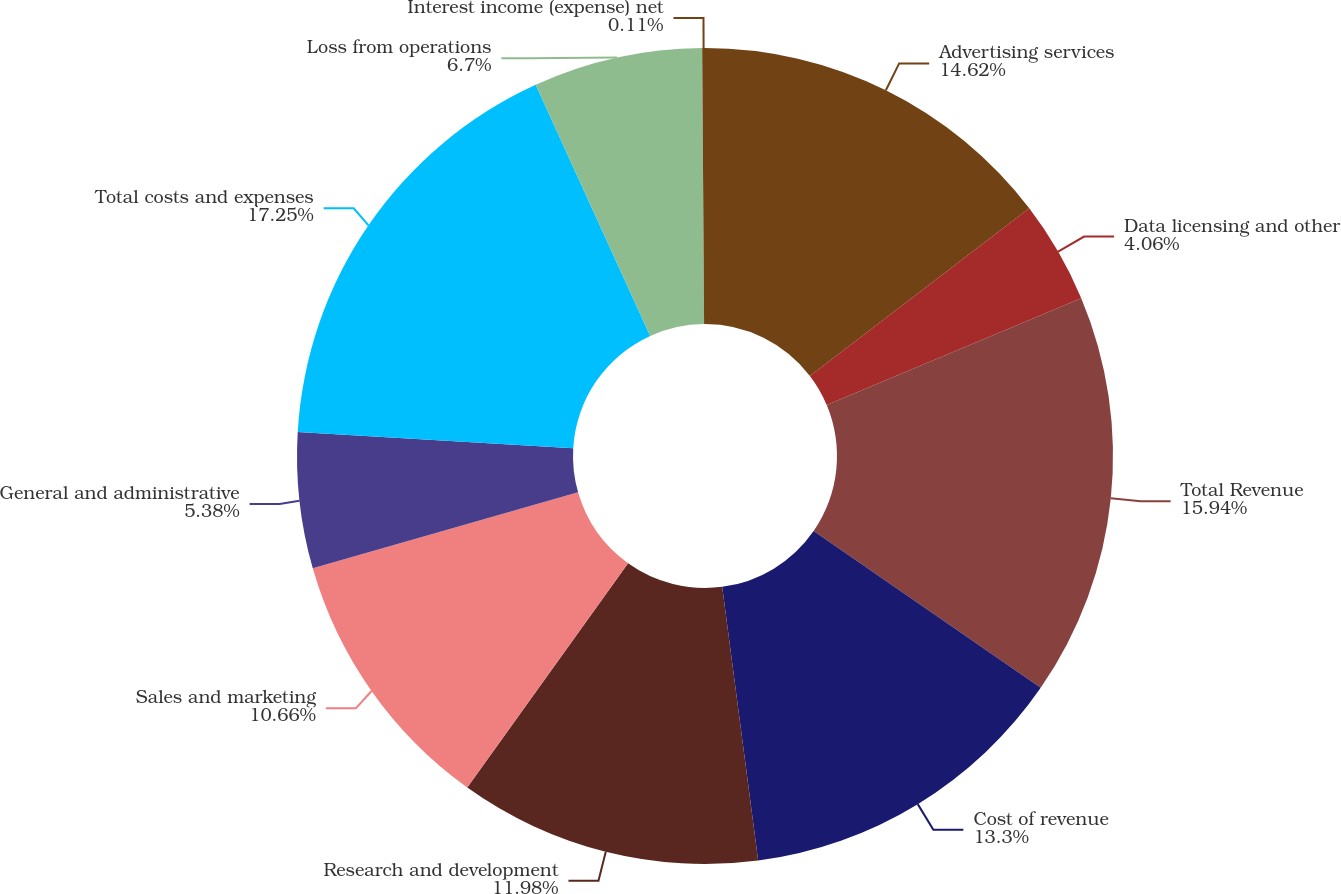<chart> <loc_0><loc_0><loc_500><loc_500><pie_chart><fcel>Advertising services<fcel>Data licensing and other<fcel>Total Revenue<fcel>Cost of revenue<fcel>Research and development<fcel>Sales and marketing<fcel>General and administrative<fcel>Total costs and expenses<fcel>Loss from operations<fcel>Interest income (expense) net<nl><fcel>14.62%<fcel>4.06%<fcel>15.94%<fcel>13.3%<fcel>11.98%<fcel>10.66%<fcel>5.38%<fcel>17.25%<fcel>6.7%<fcel>0.11%<nl></chart> 